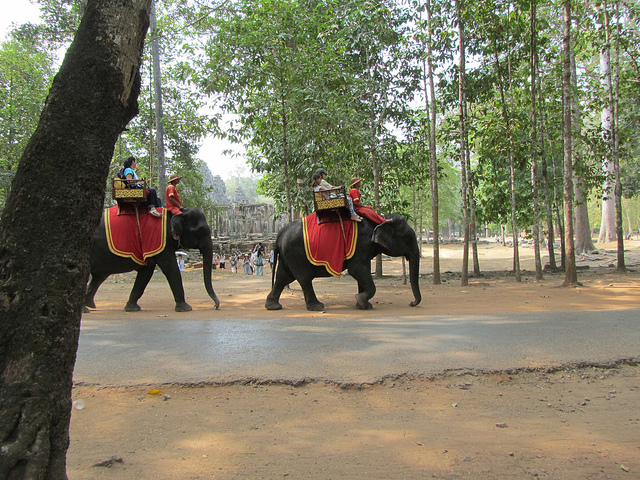How many elephants are visible? There are two elephants visible, each adorned with a decorative red cloth and carrying a person on their back, which suggests they might be offering rides to tourists. 